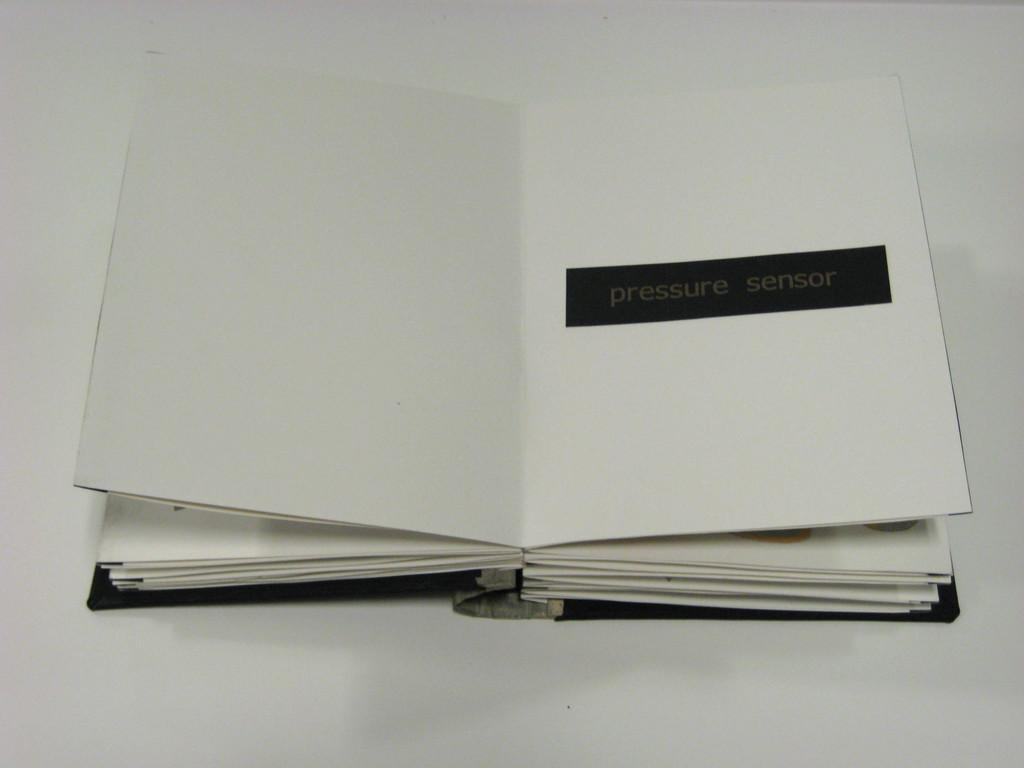<image>
Relay a brief, clear account of the picture shown. A book with plain white pages apart from the words pressure sensor in black. 